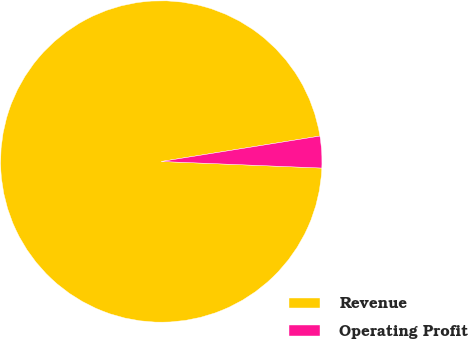Convert chart to OTSL. <chart><loc_0><loc_0><loc_500><loc_500><pie_chart><fcel>Revenue<fcel>Operating Profit<nl><fcel>96.82%<fcel>3.18%<nl></chart> 